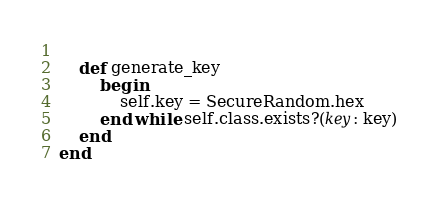<code> <loc_0><loc_0><loc_500><loc_500><_Ruby_>	
	def generate_key
		begin
			self.key = SecureRandom.hex
		end while self.class.exists?(key: key)
	end
end</code> 